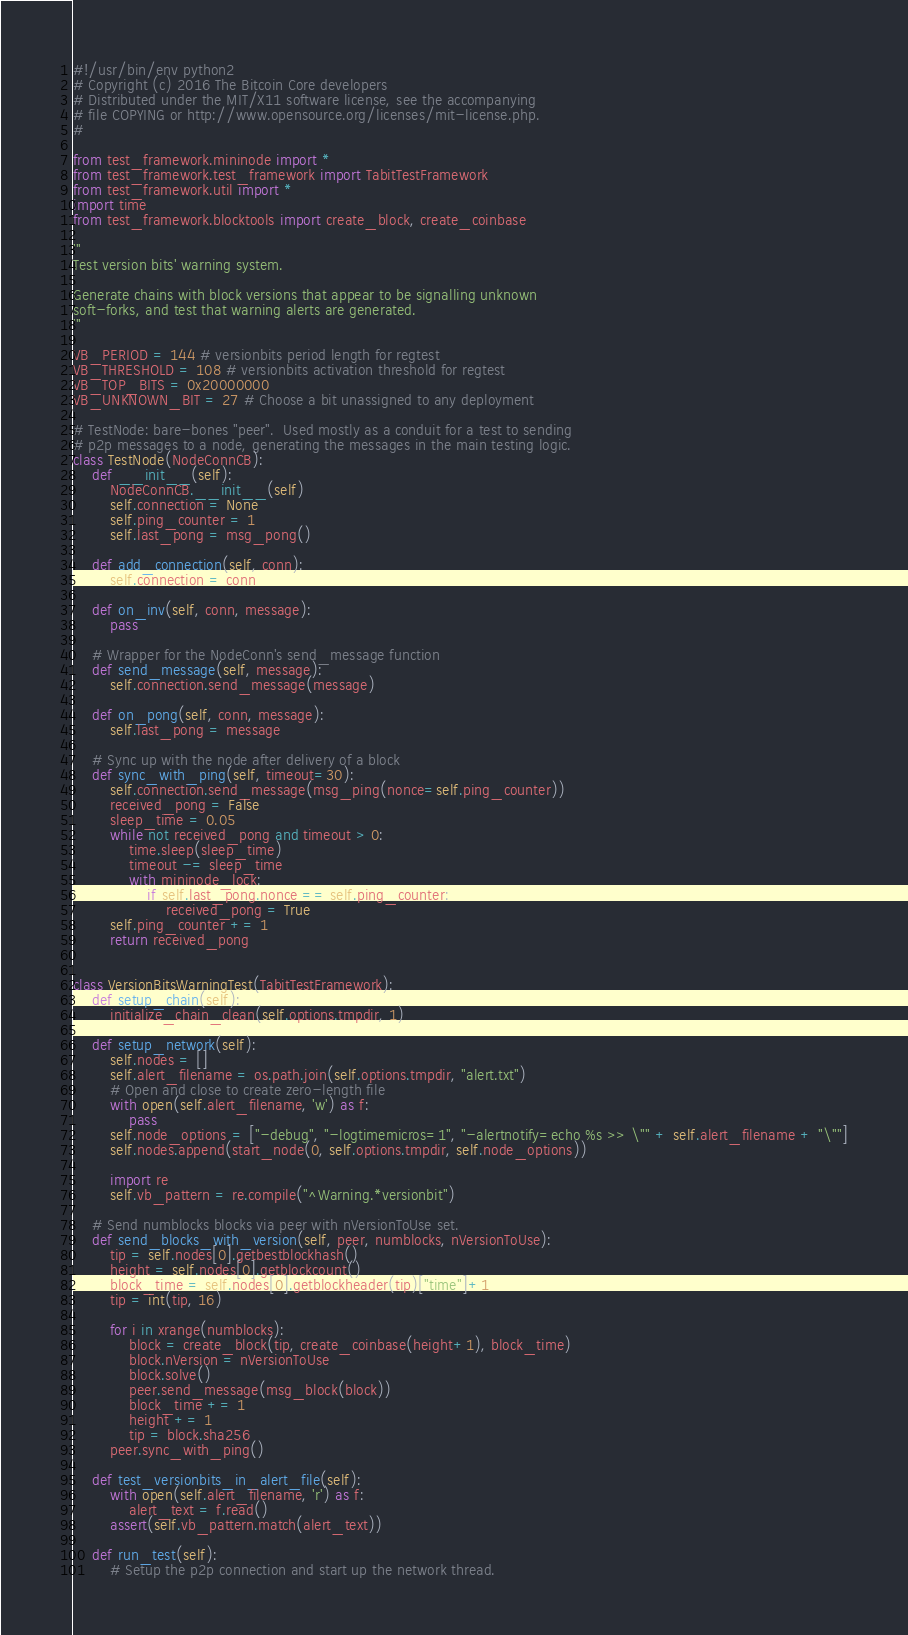<code> <loc_0><loc_0><loc_500><loc_500><_Python_>#!/usr/bin/env python2
# Copyright (c) 2016 The Bitcoin Core developers
# Distributed under the MIT/X11 software license, see the accompanying
# file COPYING or http://www.opensource.org/licenses/mit-license.php.
#

from test_framework.mininode import *
from test_framework.test_framework import TabitTestFramework
from test_framework.util import *
import time
from test_framework.blocktools import create_block, create_coinbase

'''
Test version bits' warning system.

Generate chains with block versions that appear to be signalling unknown
soft-forks, and test that warning alerts are generated.
'''

VB_PERIOD = 144 # versionbits period length for regtest
VB_THRESHOLD = 108 # versionbits activation threshold for regtest
VB_TOP_BITS = 0x20000000
VB_UNKNOWN_BIT = 27 # Choose a bit unassigned to any deployment

# TestNode: bare-bones "peer".  Used mostly as a conduit for a test to sending
# p2p messages to a node, generating the messages in the main testing logic.
class TestNode(NodeConnCB):
    def __init__(self):
        NodeConnCB.__init__(self)
        self.connection = None
        self.ping_counter = 1
        self.last_pong = msg_pong()

    def add_connection(self, conn):
        self.connection = conn

    def on_inv(self, conn, message):
        pass

    # Wrapper for the NodeConn's send_message function
    def send_message(self, message):
        self.connection.send_message(message)

    def on_pong(self, conn, message):
        self.last_pong = message

    # Sync up with the node after delivery of a block
    def sync_with_ping(self, timeout=30):
        self.connection.send_message(msg_ping(nonce=self.ping_counter))
        received_pong = False
        sleep_time = 0.05
        while not received_pong and timeout > 0:
            time.sleep(sleep_time)
            timeout -= sleep_time
            with mininode_lock:
                if self.last_pong.nonce == self.ping_counter:
                    received_pong = True
        self.ping_counter += 1
        return received_pong


class VersionBitsWarningTest(TabitTestFramework):
    def setup_chain(self):
        initialize_chain_clean(self.options.tmpdir, 1)

    def setup_network(self):
        self.nodes = []
        self.alert_filename = os.path.join(self.options.tmpdir, "alert.txt")
        # Open and close to create zero-length file
        with open(self.alert_filename, 'w') as f:
            pass
        self.node_options = ["-debug", "-logtimemicros=1", "-alertnotify=echo %s >> \"" + self.alert_filename + "\""]
        self.nodes.append(start_node(0, self.options.tmpdir, self.node_options))

        import re
        self.vb_pattern = re.compile("^Warning.*versionbit")

    # Send numblocks blocks via peer with nVersionToUse set.
    def send_blocks_with_version(self, peer, numblocks, nVersionToUse):
        tip = self.nodes[0].getbestblockhash()
        height = self.nodes[0].getblockcount()
        block_time = self.nodes[0].getblockheader(tip)["time"]+1
        tip = int(tip, 16)

        for i in xrange(numblocks):
            block = create_block(tip, create_coinbase(height+1), block_time)
            block.nVersion = nVersionToUse
            block.solve()
            peer.send_message(msg_block(block))
            block_time += 1
            height += 1
            tip = block.sha256
        peer.sync_with_ping()

    def test_versionbits_in_alert_file(self):
        with open(self.alert_filename, 'r') as f:
            alert_text = f.read()
        assert(self.vb_pattern.match(alert_text))

    def run_test(self):
        # Setup the p2p connection and start up the network thread.</code> 